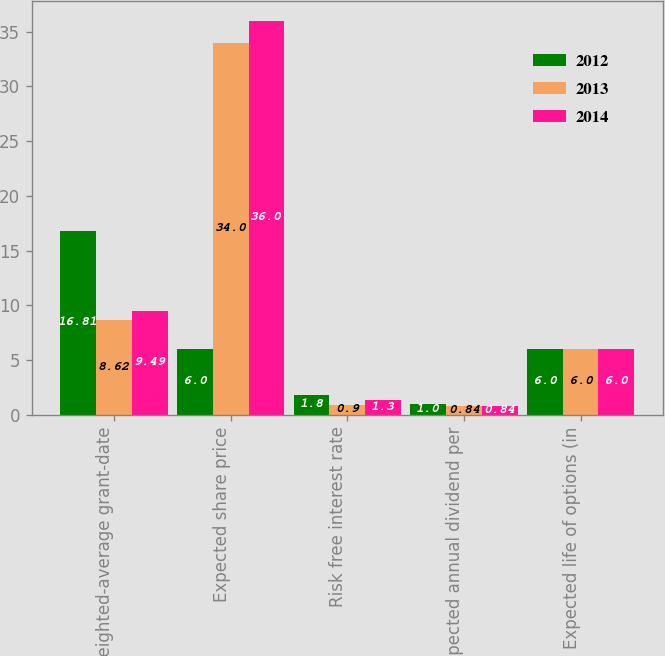Convert chart. <chart><loc_0><loc_0><loc_500><loc_500><stacked_bar_chart><ecel><fcel>Weighted-average grant-date<fcel>Expected share price<fcel>Risk free interest rate<fcel>Expected annual dividend per<fcel>Expected life of options (in<nl><fcel>2012<fcel>16.81<fcel>6<fcel>1.8<fcel>1<fcel>6<nl><fcel>2013<fcel>8.62<fcel>34<fcel>0.9<fcel>0.84<fcel>6<nl><fcel>2014<fcel>9.49<fcel>36<fcel>1.3<fcel>0.84<fcel>6<nl></chart> 